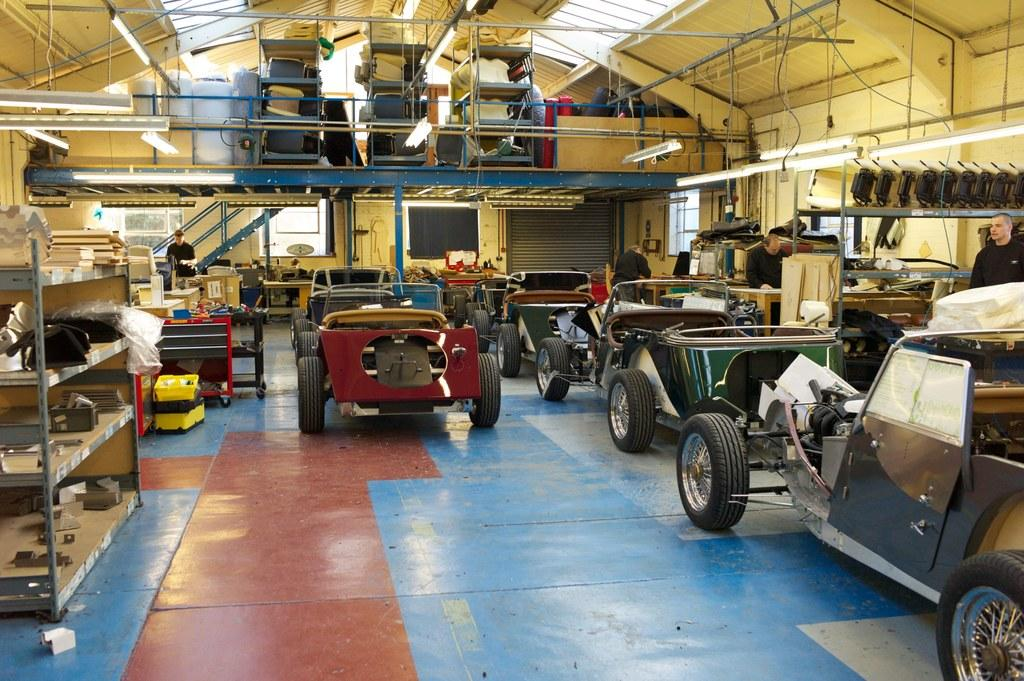What can be seen in the image in terms of transportation? There are many vehicles in the image. What are the people in the image wearing? The people in the image are wearing clothes. What is visible beneath the vehicles and people? The floor is visible in the image. What type of storage or display is present in the image? There are shelves in the image. What provides illumination in the image? Lights are present in the image. What type of infrastructure is visible in the image? Cable wires are visible in the image. What allows natural light to enter the space in the image? There is a window in the image. What type of mountain can be seen in the image? There are no mountains present in the image. What kind of clouds can be seen through the window in the image? There is no window visible in the image, and therefore no clouds can be seen. 